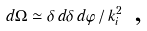Convert formula to latex. <formula><loc_0><loc_0><loc_500><loc_500>d \Omega \simeq \delta \, d \delta \, d \varphi \, / \, k _ { i } ^ { 2 } \text { ,}</formula> 